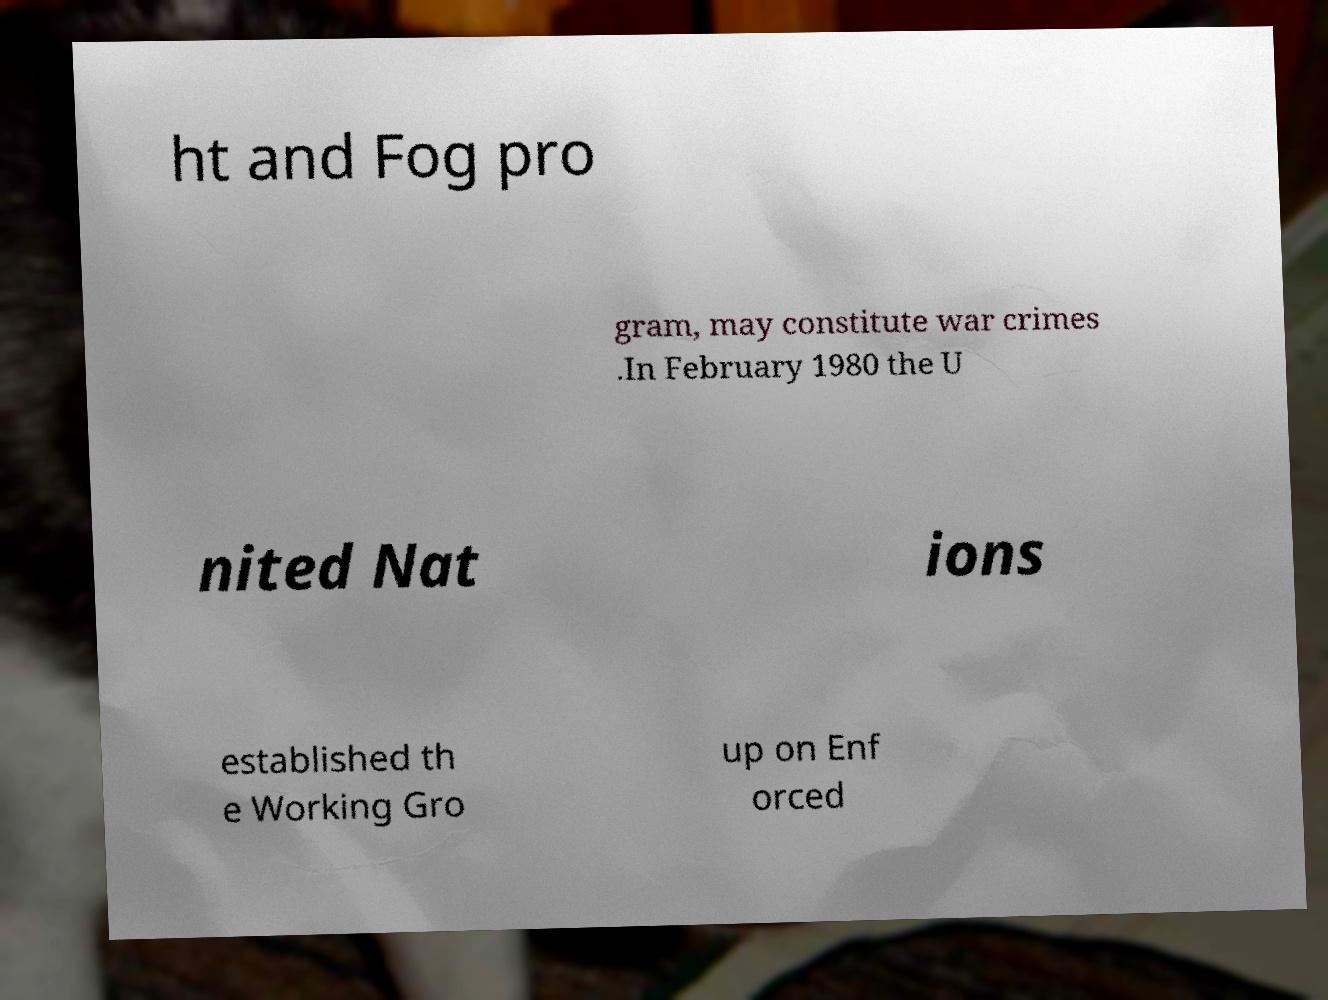There's text embedded in this image that I need extracted. Can you transcribe it verbatim? ht and Fog pro gram, may constitute war crimes .In February 1980 the U nited Nat ions established th e Working Gro up on Enf orced 